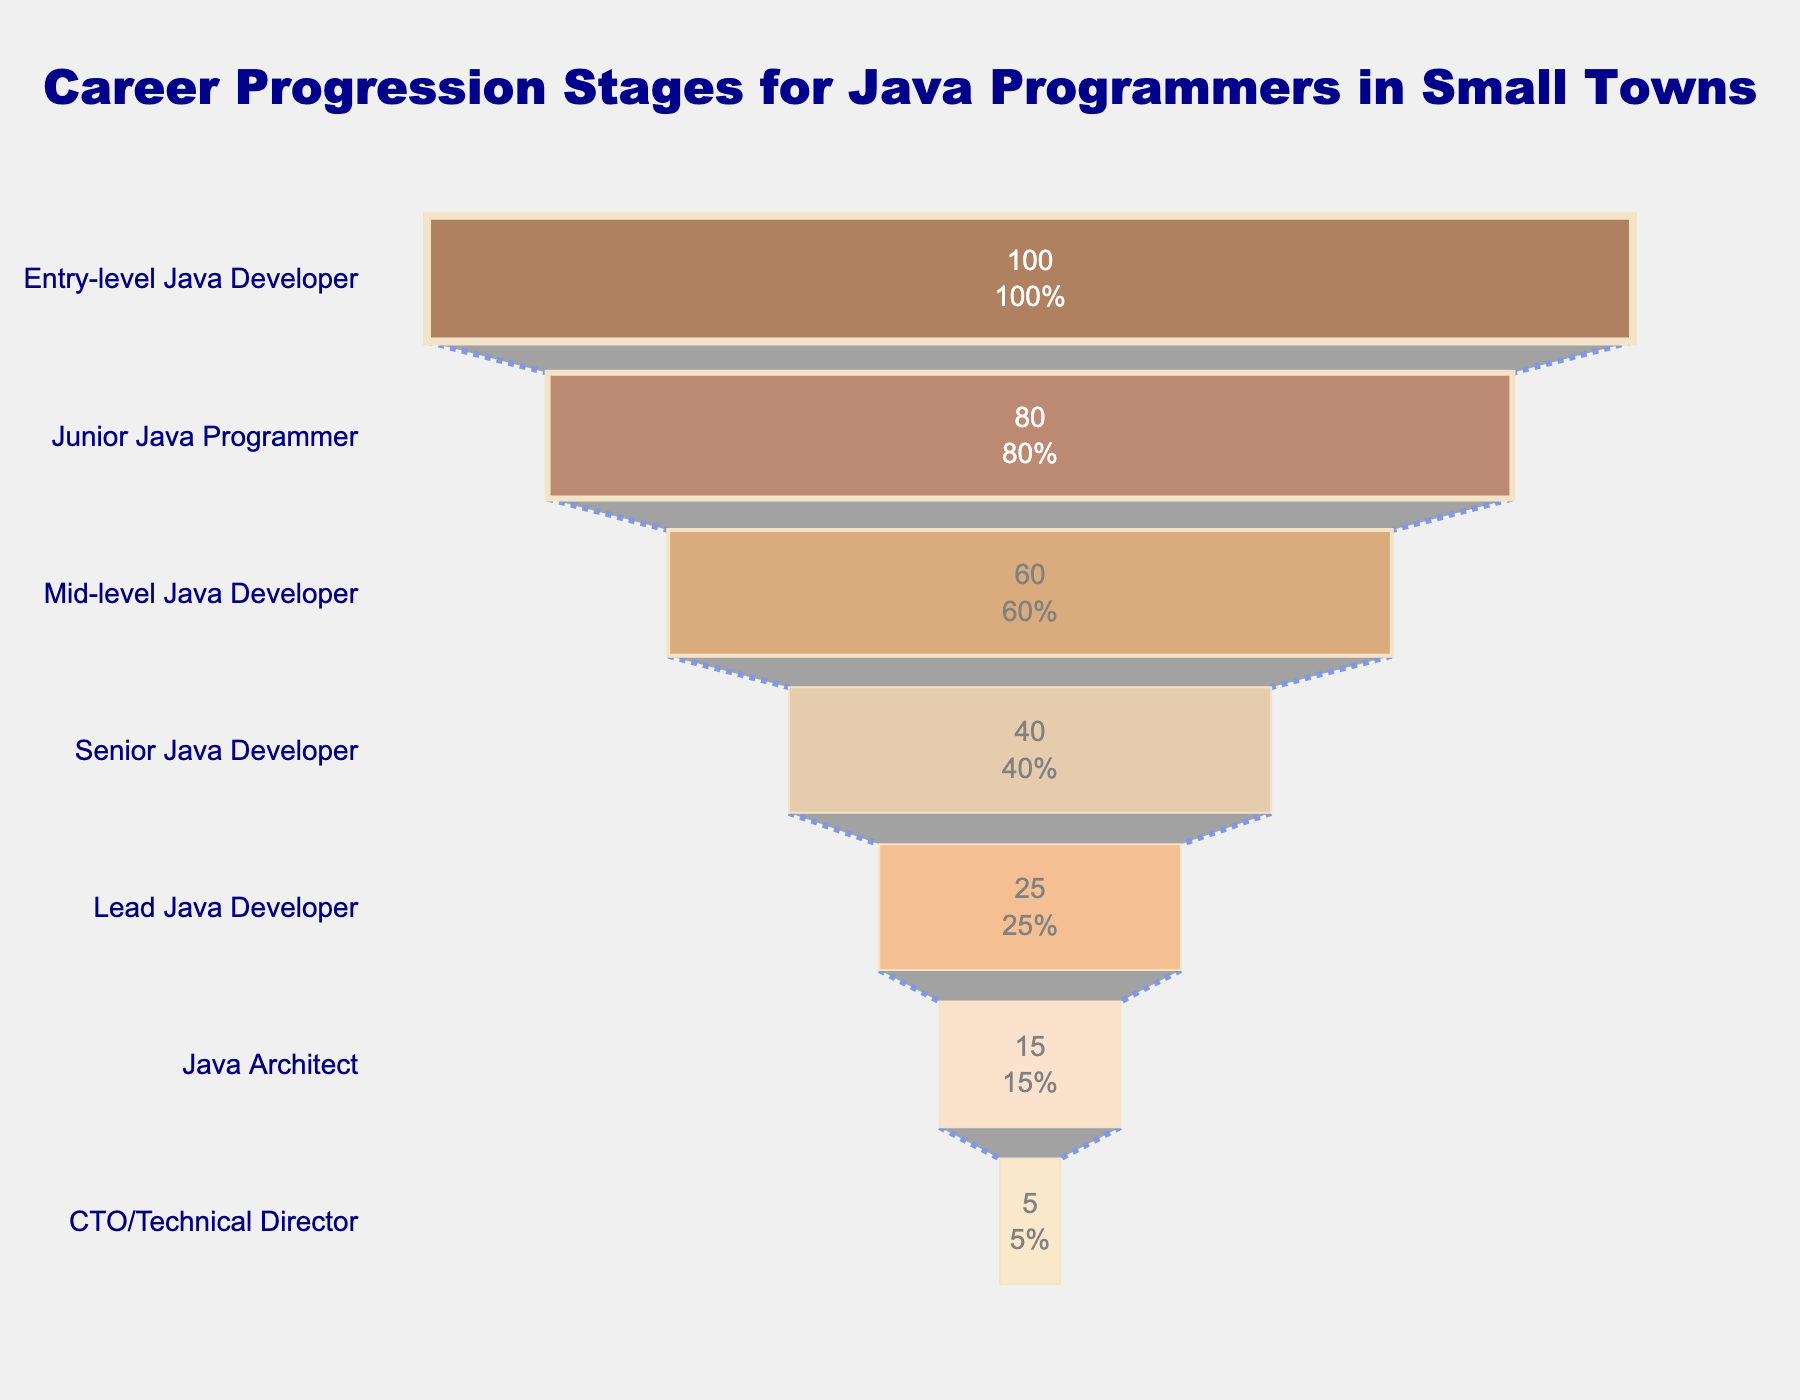How many career progression stages are visualized in this funnel chart? Count the number of unique stages listed on the y-axis.
Answer: 7 What percentage of Java programmers reach the Junior Java Programmer stage? Read the percentage value from the "Junior Java Programmer" stage on the funnel chart.
Answer: 80% What is the percentage difference between Mid-level Java Developer and Lead Java Developer? Subtract the percentage of Lead Java Developer from Mid-level Java Developer (60% - 25%).
Answer: 35% Which stage has the smallest percentage of Java programmers reaching it? Identify the stage with the lowest percentage value on the funnel chart.
Answer: CTO/Technical Director What percentage of programmers transition from Senior Java Developer to Java Architect? Read the percentage values for both stages and calculate the difference (40% - 15%).
Answer: 25% Compare the percentage of programmers in the Senior Java Developer stage to those in the Entry-level Java Developer stage. Assess the percentage values for both stages and state which one is higher.
Answer: Entry-level Java Developer (100%) How much does the percentage drop from Junior Java Programmer to Mid-level Java Developer? Find the difference in percentages between Junior Java Programmer (80%) and Mid-level Java Developer (60%).
Answer: 20% What is the most significant drop in percentage between consecutive stages? Identify the stages with the largest percentage difference by comparing the drop between each consecutive pair of stages.
Answer: Junior Java Programmer to Mid-level Java Developer (20%) How many stages have a percentage of 25% or less? Count the stages with percentage values of 25% or less.
Answer: 3 Describe the overall pattern shown in the funnel chart regarding career progression stages for Java programmers in small towns. Examine the overall trend from top to bottom and summarize the pattern indicated by the percentage reductions at each stage.
Answer: The percentage of Java programmers decreases steadily from Entry-level to CTO/Technical Director 